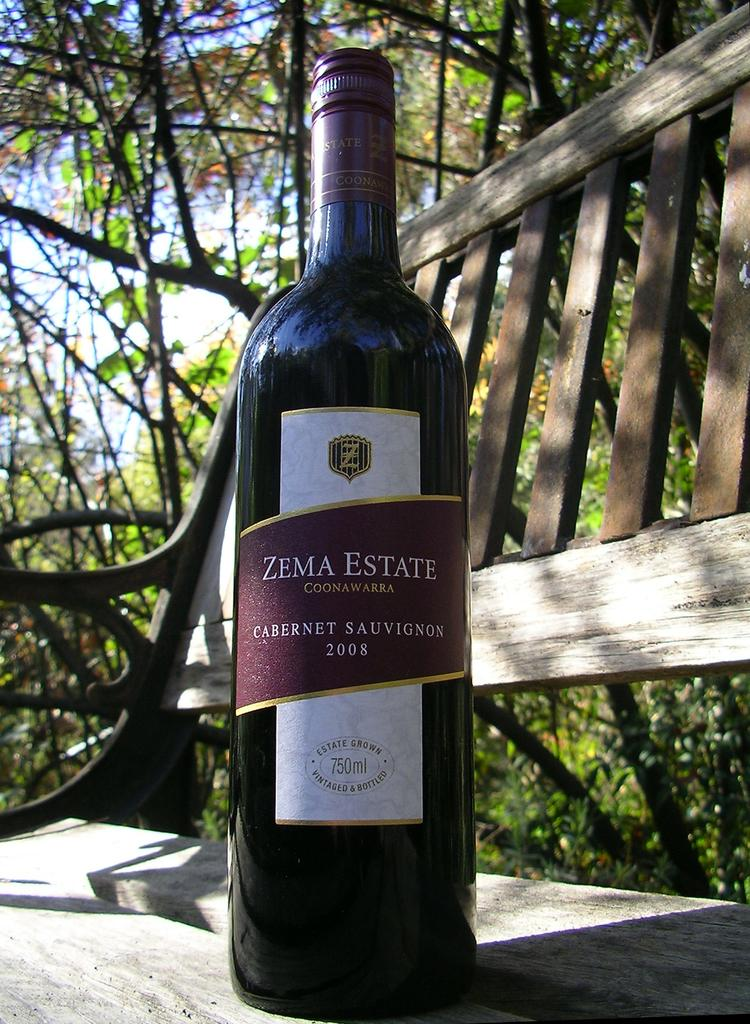<image>
Present a compact description of the photo's key features. A bottle is dated 2008 and has the Zema Estate brand logo. 